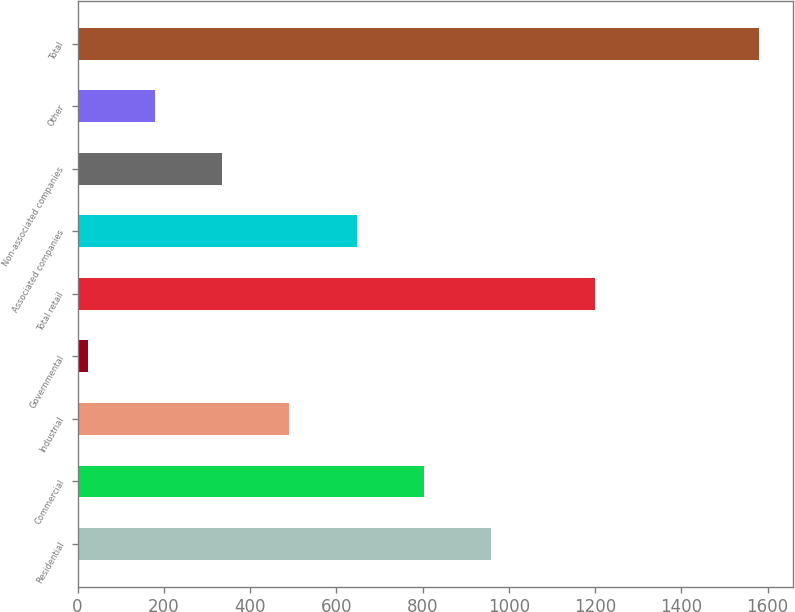<chart> <loc_0><loc_0><loc_500><loc_500><bar_chart><fcel>Residential<fcel>Commercial<fcel>Industrial<fcel>Governmental<fcel>Total retail<fcel>Associated companies<fcel>Non-associated companies<fcel>Other<fcel>Total<nl><fcel>958.2<fcel>802.5<fcel>491.1<fcel>24<fcel>1201<fcel>646.8<fcel>335.4<fcel>179.7<fcel>1581<nl></chart> 